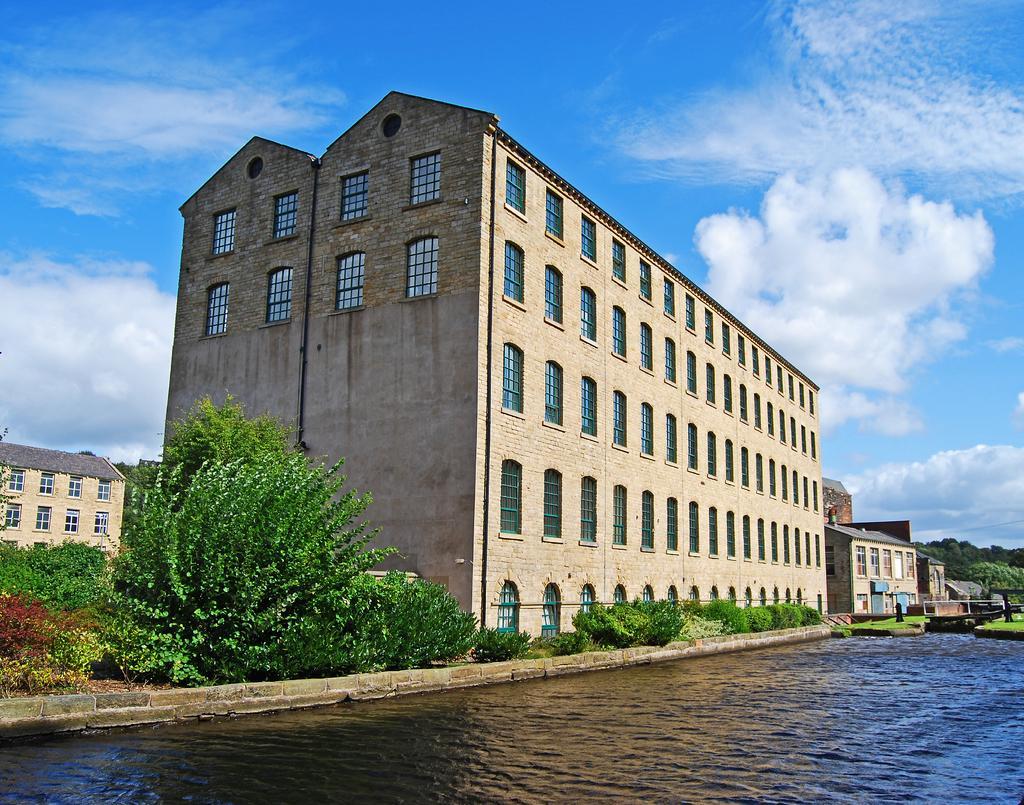Could you give a brief overview of what you see in this image? In the image there is a water surface in the foreground and behind that there are plants and buildings and on the right side beside the buildings there are trees. 